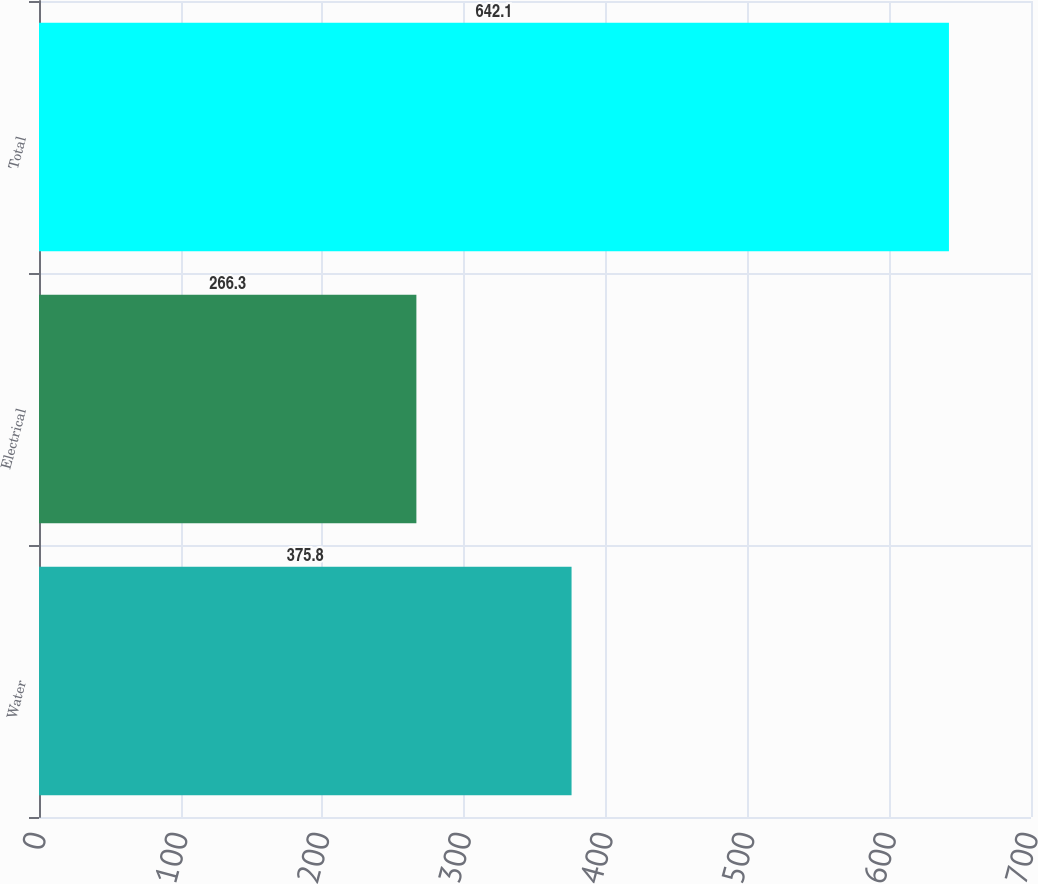Convert chart. <chart><loc_0><loc_0><loc_500><loc_500><bar_chart><fcel>Water<fcel>Electrical<fcel>Total<nl><fcel>375.8<fcel>266.3<fcel>642.1<nl></chart> 